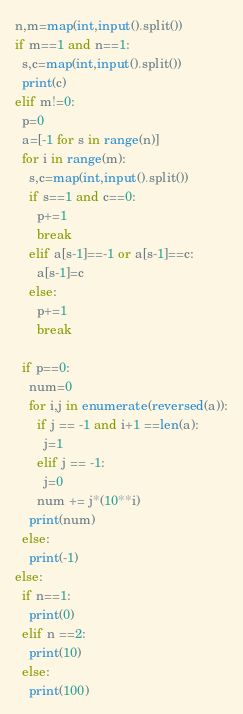Convert code to text. <code><loc_0><loc_0><loc_500><loc_500><_Python_>n,m=map(int,input().split())
if m==1 and n==1:
  s,c=map(int,input().split())
  print(c)
elif m!=0:
  p=0
  a=[-1 for s in range(n)]
  for i in range(m):
    s,c=map(int,input().split())
    if s==1 and c==0:
      p+=1
      break
    elif a[s-1]==-1 or a[s-1]==c:
      a[s-1]=c
    else:
      p+=1
      break

  if p==0:
    num=0
    for i,j in enumerate(reversed(a)):
      if j == -1 and i+1 ==len(a):
        j=1
      elif j == -1:
        j=0
      num += j*(10**i)
    print(num)
  else:
    print(-1)
else:
  if n==1:
    print(0)
  elif n ==2:
    print(10)
  else:
    print(100)</code> 